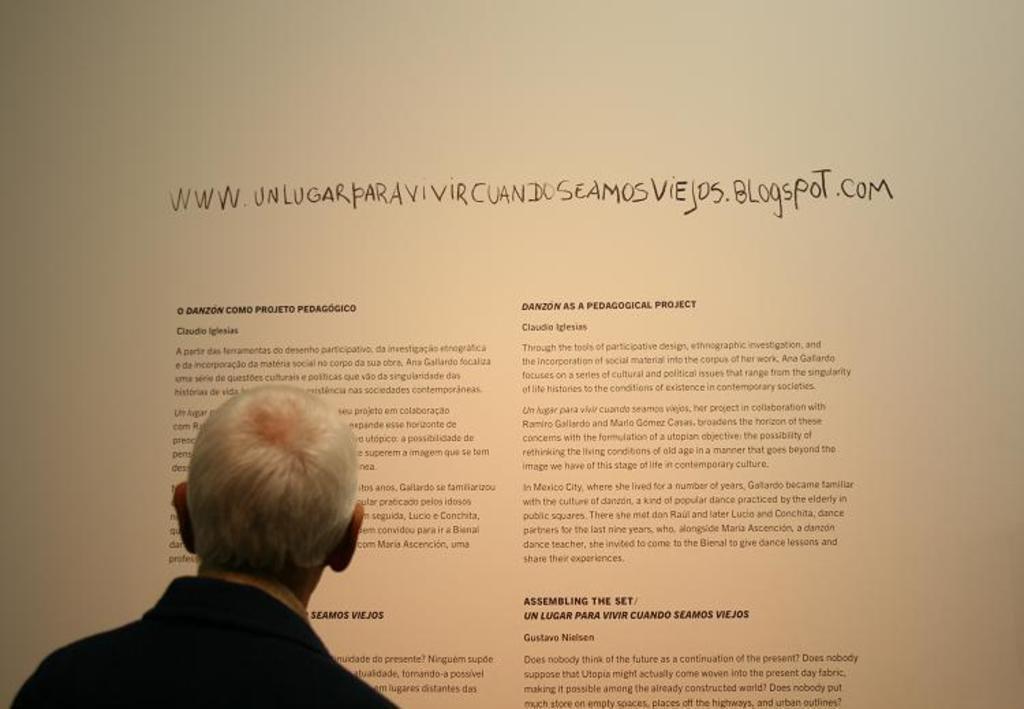Could you give a brief overview of what you see in this image? In this picture we can see the head of an old man standing in front of a board with something written on it. 